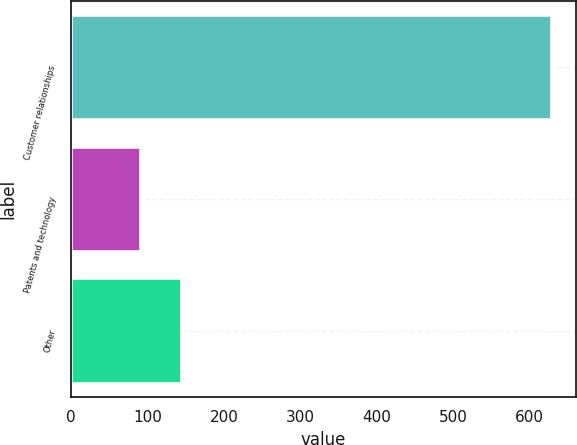<chart> <loc_0><loc_0><loc_500><loc_500><bar_chart><fcel>Customer relationships<fcel>Patents and technology<fcel>Other<nl><fcel>629.2<fcel>91.3<fcel>145.09<nl></chart> 